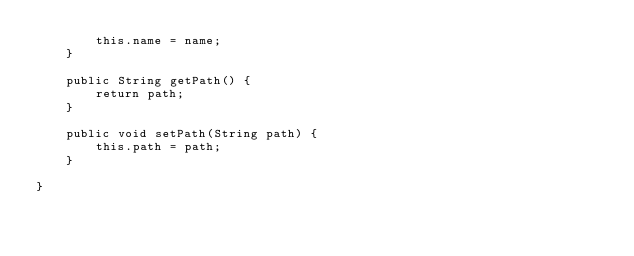Convert code to text. <code><loc_0><loc_0><loc_500><loc_500><_Java_>        this.name = name;
    }

    public String getPath() {
        return path;
    }

    public void setPath(String path) {
        this.path = path;
    }

}
</code> 